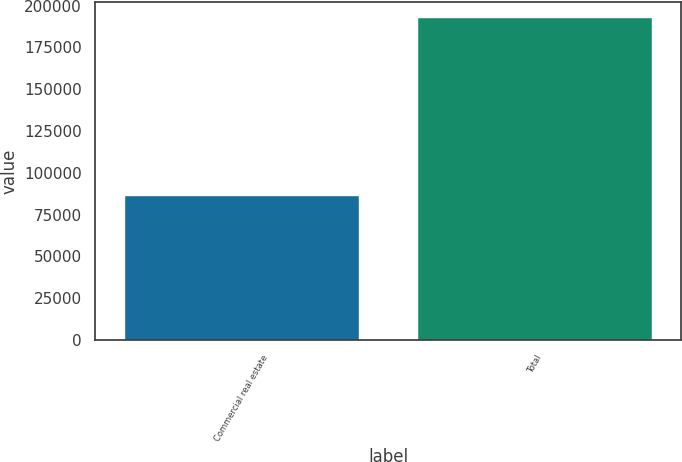Convert chart. <chart><loc_0><loc_0><loc_500><loc_500><bar_chart><fcel>Commercial real estate<fcel>Total<nl><fcel>86121<fcel>192744<nl></chart> 